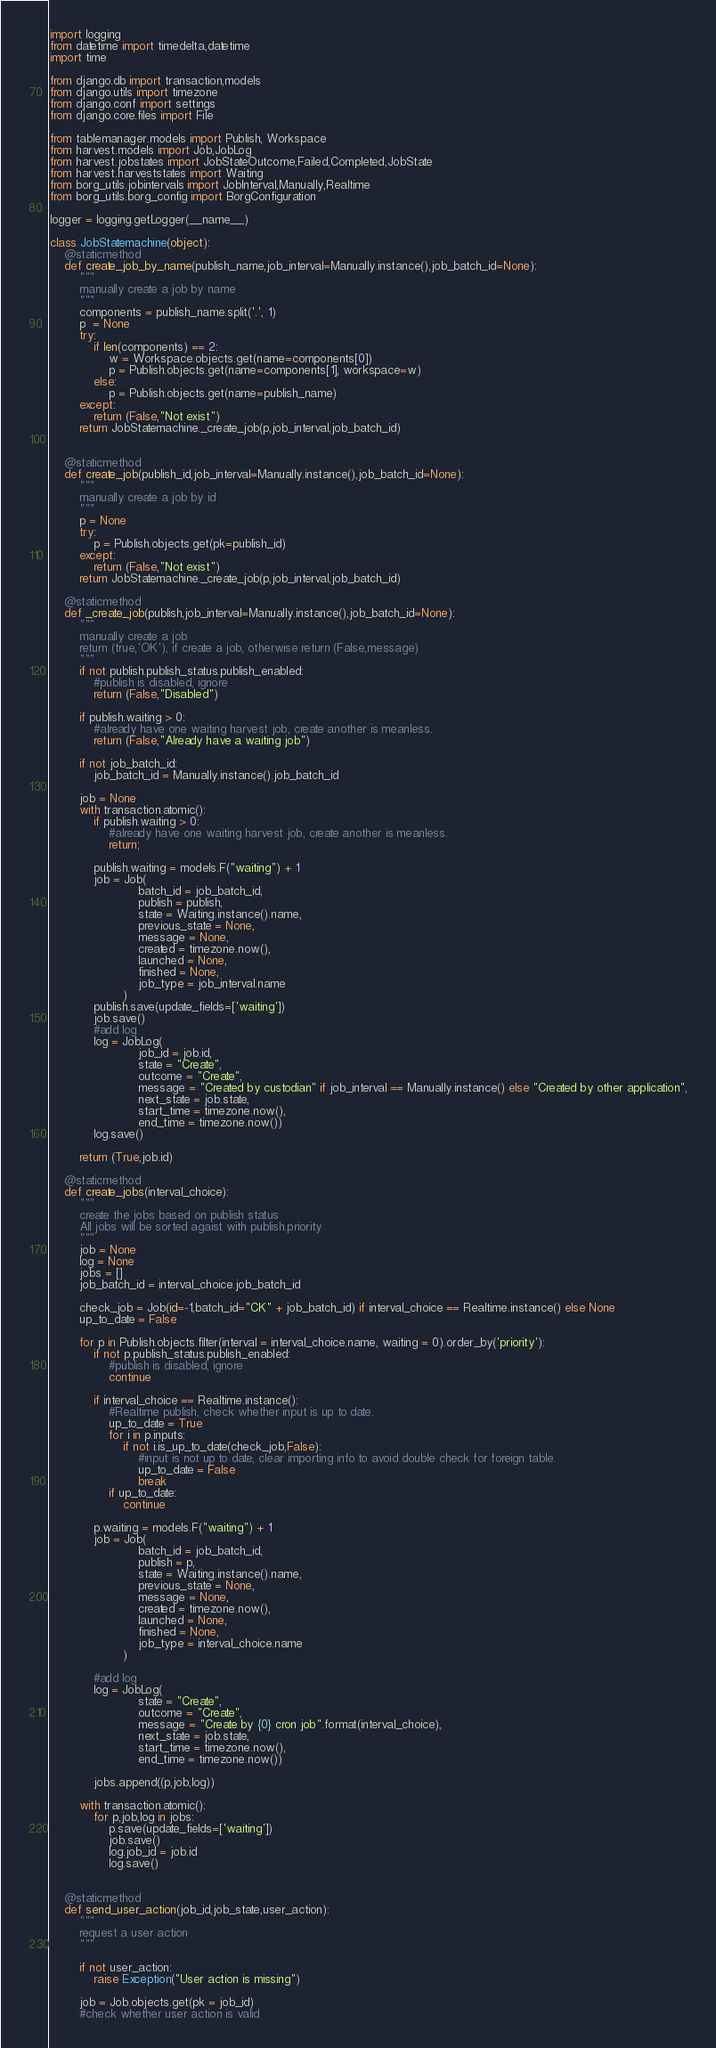Convert code to text. <code><loc_0><loc_0><loc_500><loc_500><_Python_>import logging
from datetime import timedelta,datetime
import time

from django.db import transaction,models
from django.utils import timezone
from django.conf import settings
from django.core.files import File

from tablemanager.models import Publish, Workspace
from harvest.models import Job,JobLog
from harvest.jobstates import JobStateOutcome,Failed,Completed,JobState
from harvest.harveststates import Waiting
from borg_utils.jobintervals import JobInterval,Manually,Realtime
from borg_utils.borg_config import BorgConfiguration

logger = logging.getLogger(__name__)

class JobStatemachine(object):
    @staticmethod
    def create_job_by_name(publish_name,job_interval=Manually.instance(),job_batch_id=None):
        """
        manually create a job by name
        """
        components = publish_name.split('.', 1)
        p  = None
        try:
            if len(components) == 2:
                w = Workspace.objects.get(name=components[0])
                p = Publish.objects.get(name=components[1], workspace=w)
            else:
                p = Publish.objects.get(name=publish_name)
        except:
            return (False,"Not exist")
        return JobStatemachine._create_job(p,job_interval,job_batch_id)


    @staticmethod
    def create_job(publish_id,job_interval=Manually.instance(),job_batch_id=None):
        """
        manually create a job by id
        """
        p = None
        try:
            p = Publish.objects.get(pk=publish_id)
        except:
            return (False,"Not exist")
        return JobStatemachine._create_job(p,job_interval,job_batch_id)

    @staticmethod
    def _create_job(publish,job_interval=Manually.instance(),job_batch_id=None):
        """
        manually create a job
        return (true,'OK'), if create a job, otherwise return (False,message)
        """
        if not publish.publish_status.publish_enabled:
            #publish is disabled, ignore
            return (False,"Disabled")

        if publish.waiting > 0:
            #already have one waiting harvest job, create another is meanless.
            return (False,"Already have a waiting job")

        if not job_batch_id:
            job_batch_id = Manually.instance().job_batch_id

        job = None
        with transaction.atomic():
            if publish.waiting > 0:
                #already have one waiting harvest job, create another is meanless.
                return;

            publish.waiting = models.F("waiting") + 1
            job = Job(
                        batch_id = job_batch_id,
                        publish = publish,
                        state = Waiting.instance().name,
                        previous_state = None,
                        message = None,
                        created = timezone.now(),
                        launched = None,
                        finished = None,
                        job_type = job_interval.name
                    )
            publish.save(update_fields=['waiting'])
            job.save()
            #add log
            log = JobLog(
                        job_id = job.id,
                        state = "Create",
                        outcome = "Create",
                        message = "Created by custodian" if job_interval == Manually.instance() else "Created by other application",
                        next_state = job.state,
                        start_time = timezone.now(),
                        end_time = timezone.now())
            log.save()

        return (True,job.id)

    @staticmethod
    def create_jobs(interval_choice):
        """
        create the jobs based on publish status
        All jobs will be sorted agaist with publish.priority
        """
        job = None
        log = None
        jobs = []
        job_batch_id = interval_choice.job_batch_id

        check_job = Job(id=-1,batch_id="CK" + job_batch_id) if interval_choice == Realtime.instance() else None
        up_to_date = False
        
        for p in Publish.objects.filter(interval = interval_choice.name, waiting = 0).order_by('priority'):
            if not p.publish_status.publish_enabled:
                #publish is disabled, ignore
                continue

            if interval_choice == Realtime.instance():
                #Realtime publish, check whether input is up to date.
                up_to_date = True
                for i in p.inputs:
                    if not i.is_up_to_date(check_job,False):
                        #input is not up to date, clear importing info to avoid double check for foreign table.
                        up_to_date = False
                        break
                if up_to_date:
                    continue

            p.waiting = models.F("waiting") + 1
            job = Job(
                        batch_id = job_batch_id,
                        publish = p,
                        state = Waiting.instance().name,
                        previous_state = None,
                        message = None,
                        created = timezone.now(),
                        launched = None,
                        finished = None,
                        job_type = interval_choice.name
                    )

            #add log
            log = JobLog(
                        state = "Create",
                        outcome = "Create",
                        message = "Create by {0} cron job".format(interval_choice),
                        next_state = job.state,
                        start_time = timezone.now(),
                        end_time = timezone.now())

            jobs.append((p,job,log))

        with transaction.atomic():
            for p,job,log in jobs:
                p.save(update_fields=['waiting'])
                job.save()
                log.job_id = job.id
                log.save()


    @staticmethod
    def send_user_action(job_id,job_state,user_action):
        """
        request a user action
        """

        if not user_action:
            raise Exception("User action is missing")

        job = Job.objects.get(pk = job_id)
        #check whether user action is valid</code> 